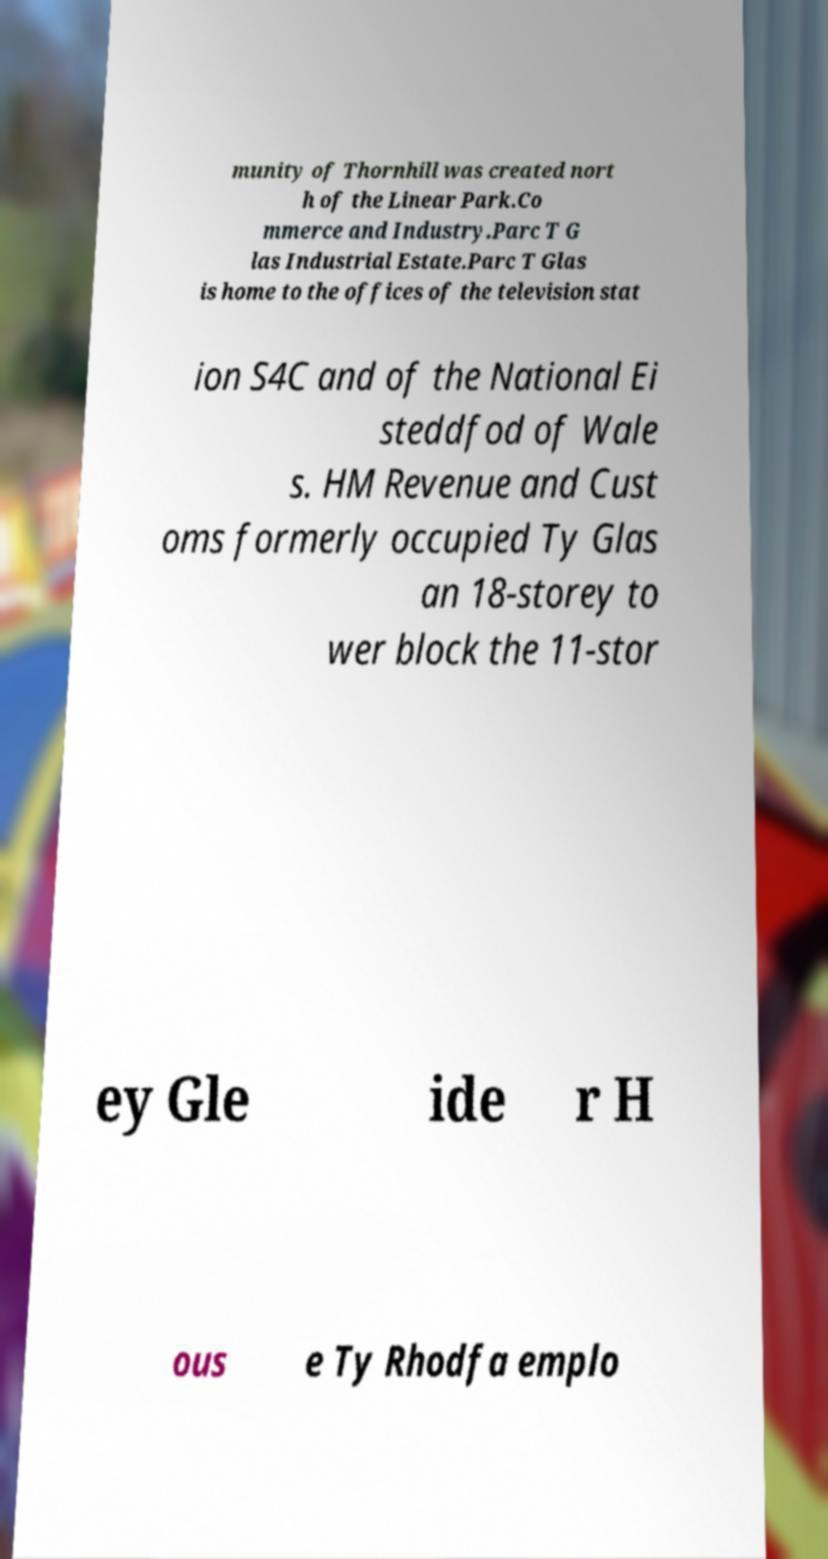Can you accurately transcribe the text from the provided image for me? munity of Thornhill was created nort h of the Linear Park.Co mmerce and Industry.Parc T G las Industrial Estate.Parc T Glas is home to the offices of the television stat ion S4C and of the National Ei steddfod of Wale s. HM Revenue and Cust oms formerly occupied Ty Glas an 18-storey to wer block the 11-stor ey Gle ide r H ous e Ty Rhodfa emplo 